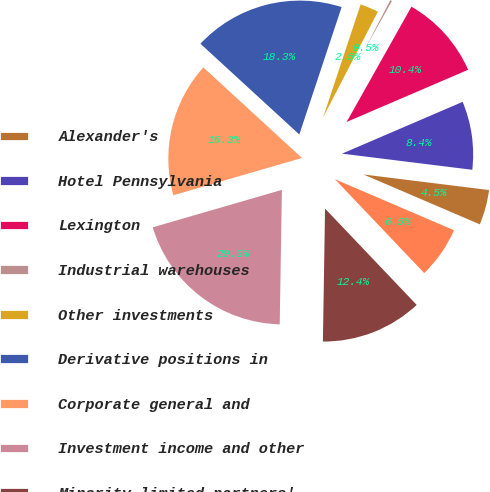<chart> <loc_0><loc_0><loc_500><loc_500><pie_chart><fcel>Alexander's<fcel>Hotel Pennsylvania<fcel>Lexington<fcel>Industrial warehouses<fcel>Other investments<fcel>Derivative positions in<fcel>Corporate general and<fcel>Investment income and other<fcel>Minority limited partners'<fcel>Perpetual preferred unit<nl><fcel>4.48%<fcel>8.42%<fcel>10.39%<fcel>0.54%<fcel>2.51%<fcel>18.28%<fcel>16.31%<fcel>20.25%<fcel>12.36%<fcel>6.45%<nl></chart> 